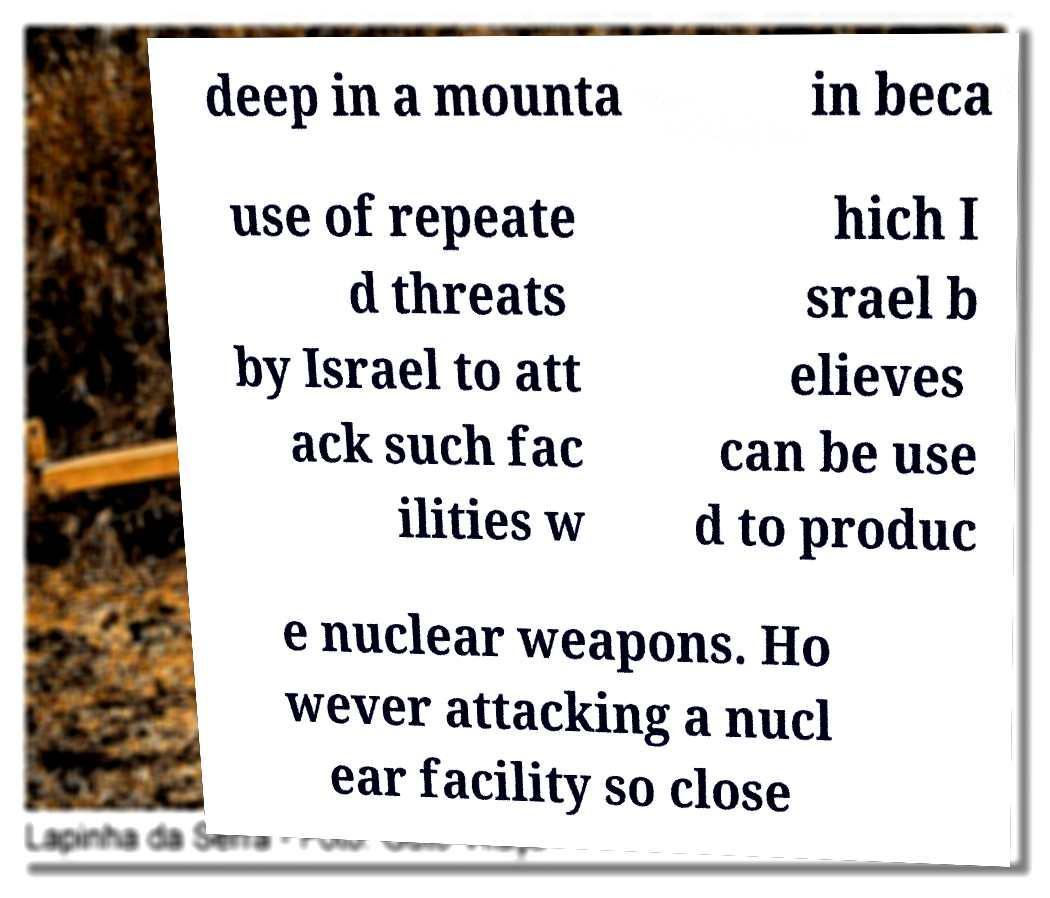Please identify and transcribe the text found in this image. deep in a mounta in beca use of repeate d threats by Israel to att ack such fac ilities w hich I srael b elieves can be use d to produc e nuclear weapons. Ho wever attacking a nucl ear facility so close 